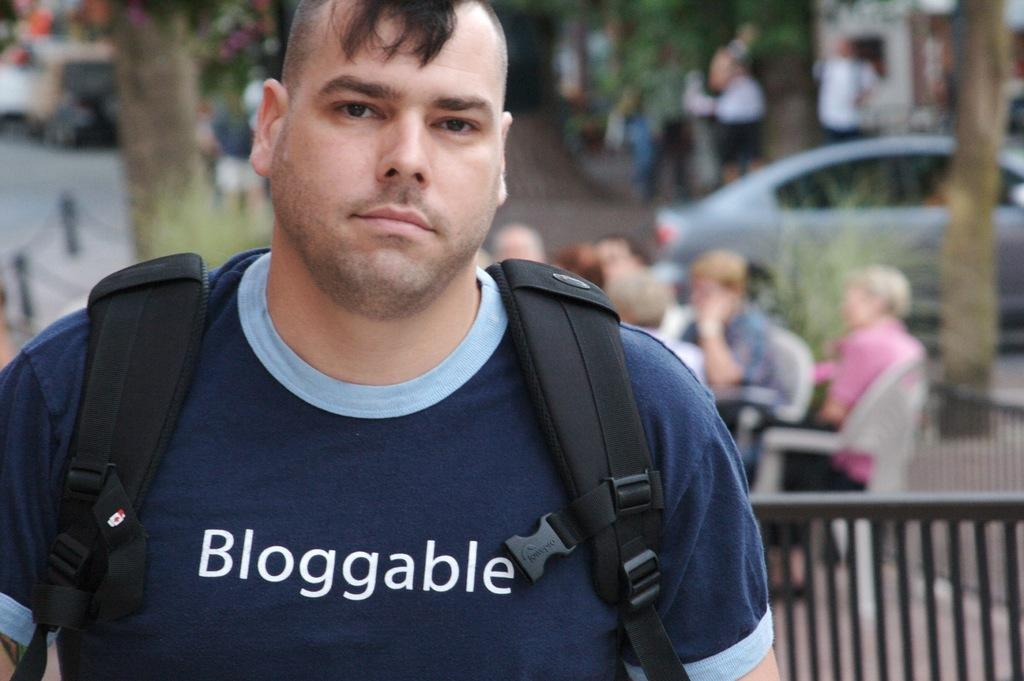How many people are in the image? There are people in the image, but the exact number is not specified. What are some of the people doing in the image? Some of the people are sitting on chairs. Can you describe any accessories or belongings that a person is wearing in the image? One person is wearing a backpack. What type of structure or object can be seen in the image? There is a railing in the image. What type of vehicle is visible in the image? There is a car in the image. What type of plant or vegetation is present in the image? There is a tree in the image. How would you describe the background of the image? The background of the image is blurred. What type of bait is being used by the person holding a fishing rod in the image? There is no fishing rod or bait present in the image. Can you describe the pocket of the person wearing a jacket in the image? There is no person wearing a jacket in the image. 